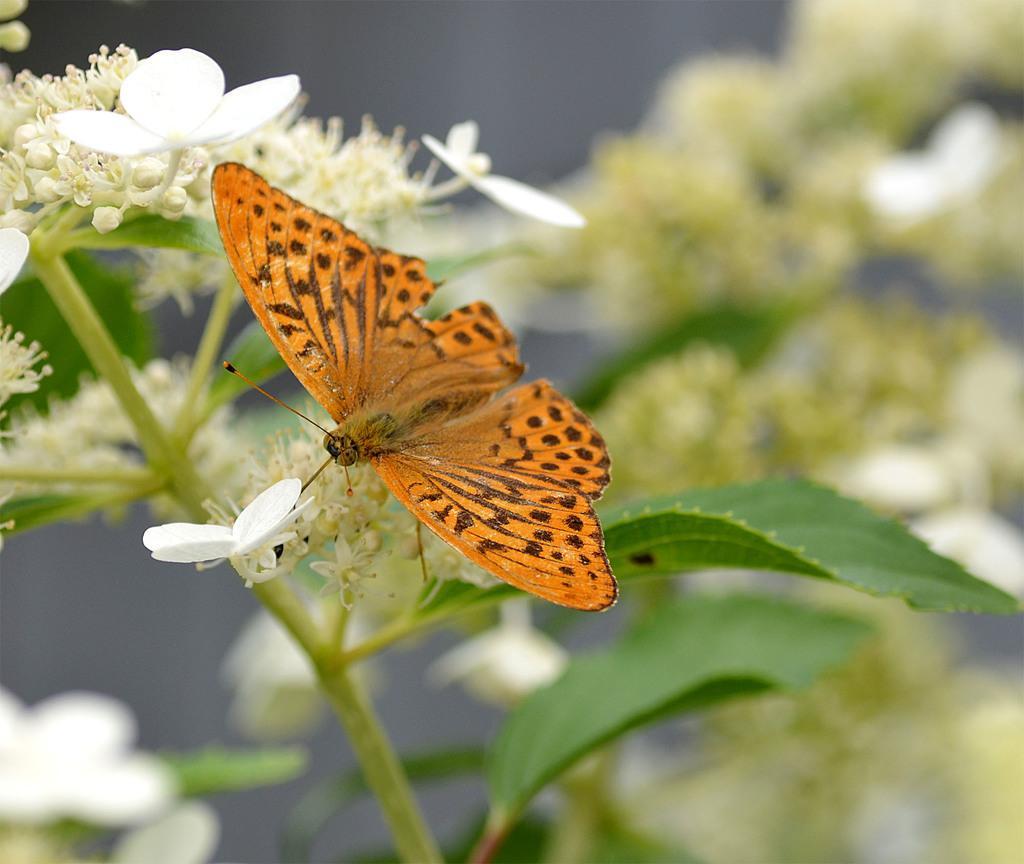Can you describe this image briefly? In this image we can see some flowers, buds and a butterfly on the plant. 